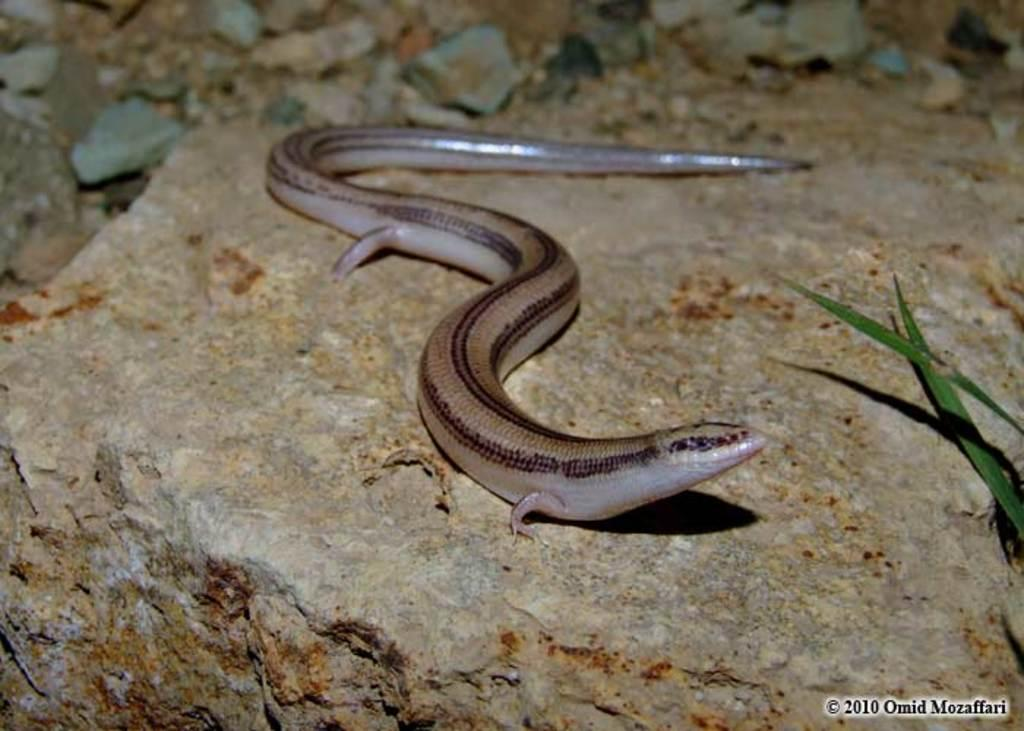What type of animal is present in the image? There is a snake in the image. What other objects can be seen in the image? There are stones and leaves visible in the image. Is there any text or numbers present in the image? Yes, there is some text and numbers written on the image. How many wheels are attached to the bike in the image? There is no bike present in the image, so it is not possible to determine the number of wheels. 